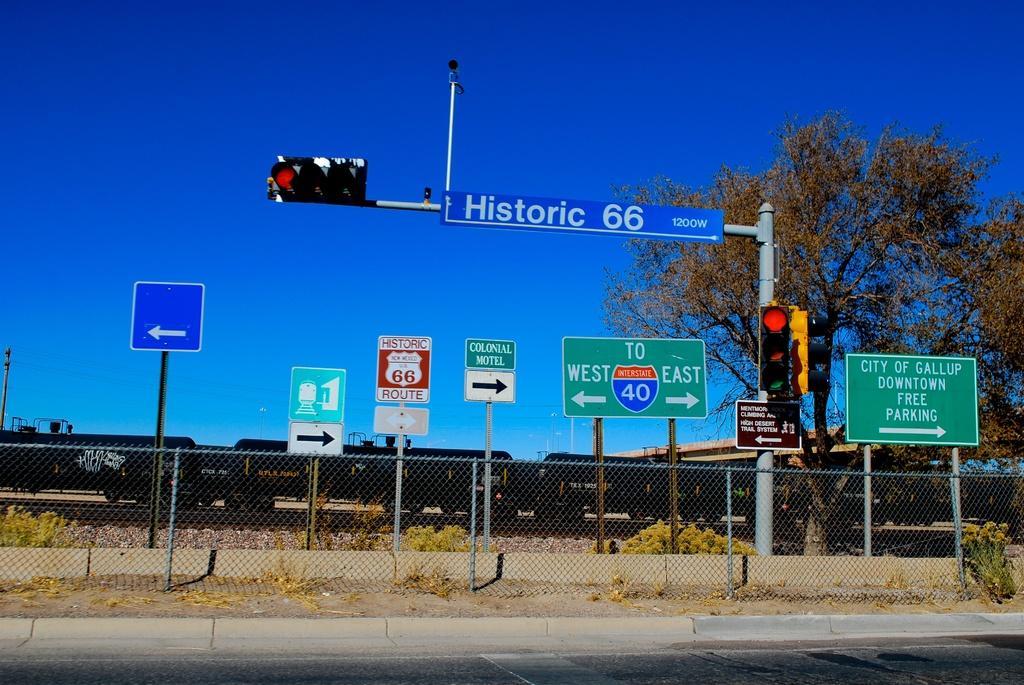Please provide a concise description of this image. In this image there is a fence on the pavement. Behind there are few poles having boards attached to it. Right side there is a pole having few traffic lights and boards are attached to it. Right side there is a tree. Behind there is a train. Top of the image there is sky. Bottom of the image there is a road. 